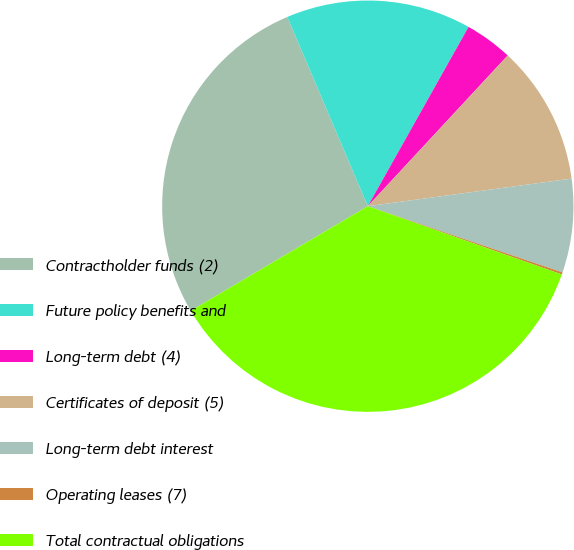Convert chart. <chart><loc_0><loc_0><loc_500><loc_500><pie_chart><fcel>Contractholder funds (2)<fcel>Future policy benefits and<fcel>Long-term debt (4)<fcel>Certificates of deposit (5)<fcel>Long-term debt interest<fcel>Operating leases (7)<fcel>Total contractual obligations<nl><fcel>27.09%<fcel>14.55%<fcel>3.76%<fcel>10.95%<fcel>7.36%<fcel>0.17%<fcel>36.12%<nl></chart> 